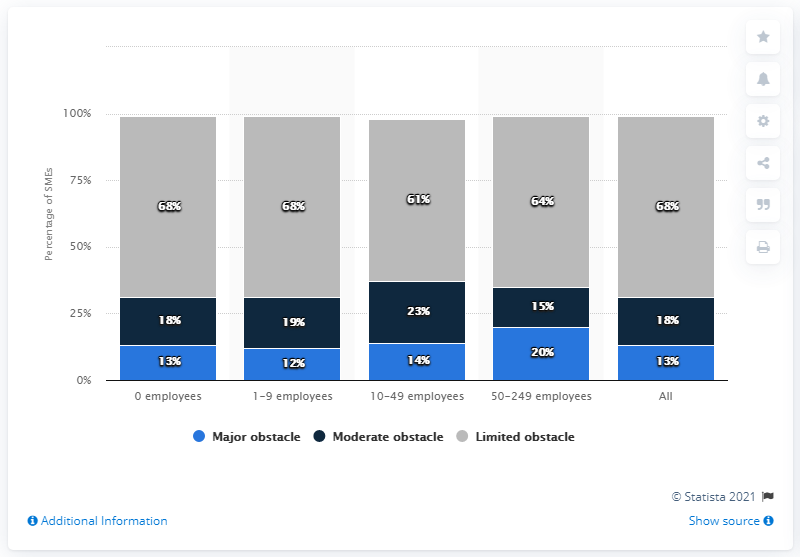Specify some key components in this picture. According to the survey, 13% of all SMEs expected cash flow/payment issues to be a significant hindrance to the operation of their business. 